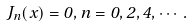Convert formula to latex. <formula><loc_0><loc_0><loc_500><loc_500>J _ { n } ( x ) = 0 , n = 0 , 2 , 4 , \cdots .</formula> 